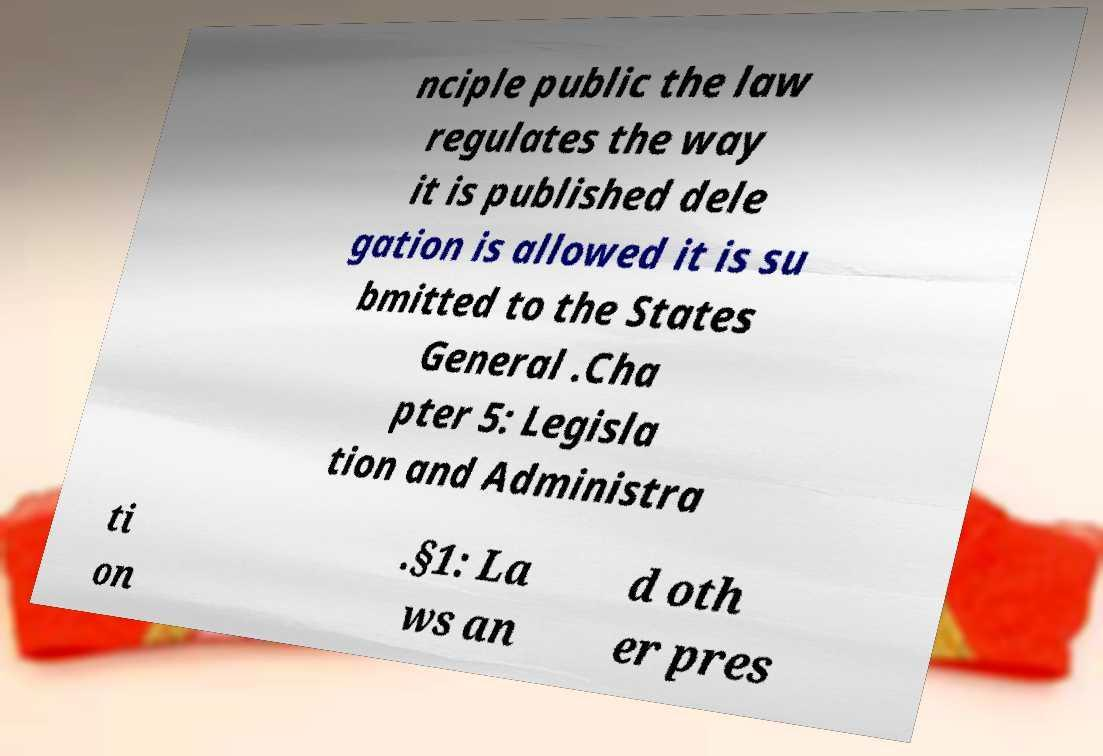There's text embedded in this image that I need extracted. Can you transcribe it verbatim? nciple public the law regulates the way it is published dele gation is allowed it is su bmitted to the States General .Cha pter 5: Legisla tion and Administra ti on .§1: La ws an d oth er pres 